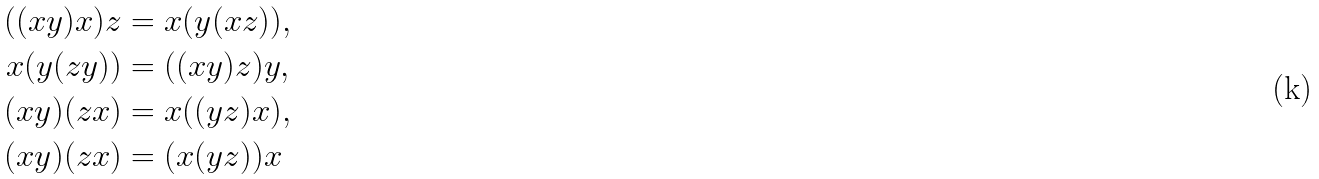Convert formula to latex. <formula><loc_0><loc_0><loc_500><loc_500>( ( x y ) x ) z & = x ( y ( x z ) ) , \\ x ( y ( z y ) ) & = ( ( x y ) z ) y , \\ ( x y ) ( z x ) & = x ( ( y z ) x ) , \\ ( x y ) ( z x ) & = ( x ( y z ) ) x</formula> 